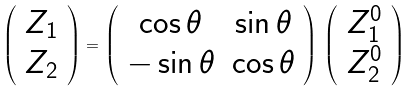Convert formula to latex. <formula><loc_0><loc_0><loc_500><loc_500>\left ( \begin{array} { c } Z _ { 1 } \\ Z _ { 2 } \end{array} \right ) = \left ( \begin{array} { c c } \cos \theta & \sin \theta \\ - \sin \theta & \cos \theta \end{array} \right ) \, \left ( \begin{array} { c } Z ^ { 0 } _ { 1 } \\ Z ^ { 0 } _ { 2 } \end{array} \right ) \,</formula> 